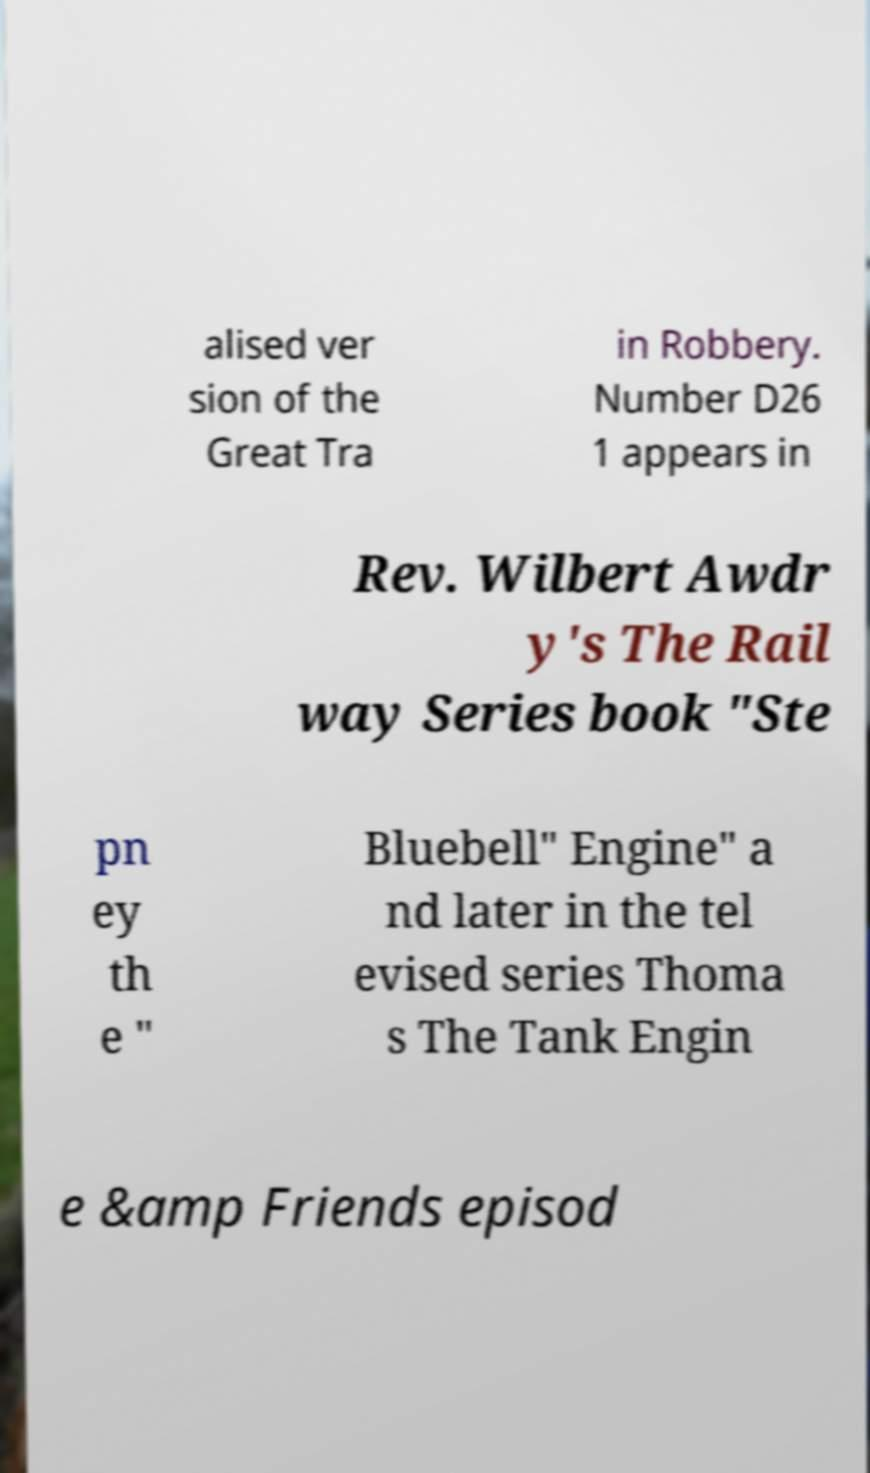Please read and relay the text visible in this image. What does it say? alised ver sion of the Great Tra in Robbery. Number D26 1 appears in Rev. Wilbert Awdr y's The Rail way Series book "Ste pn ey th e " Bluebell" Engine" a nd later in the tel evised series Thoma s The Tank Engin e &amp Friends episod 